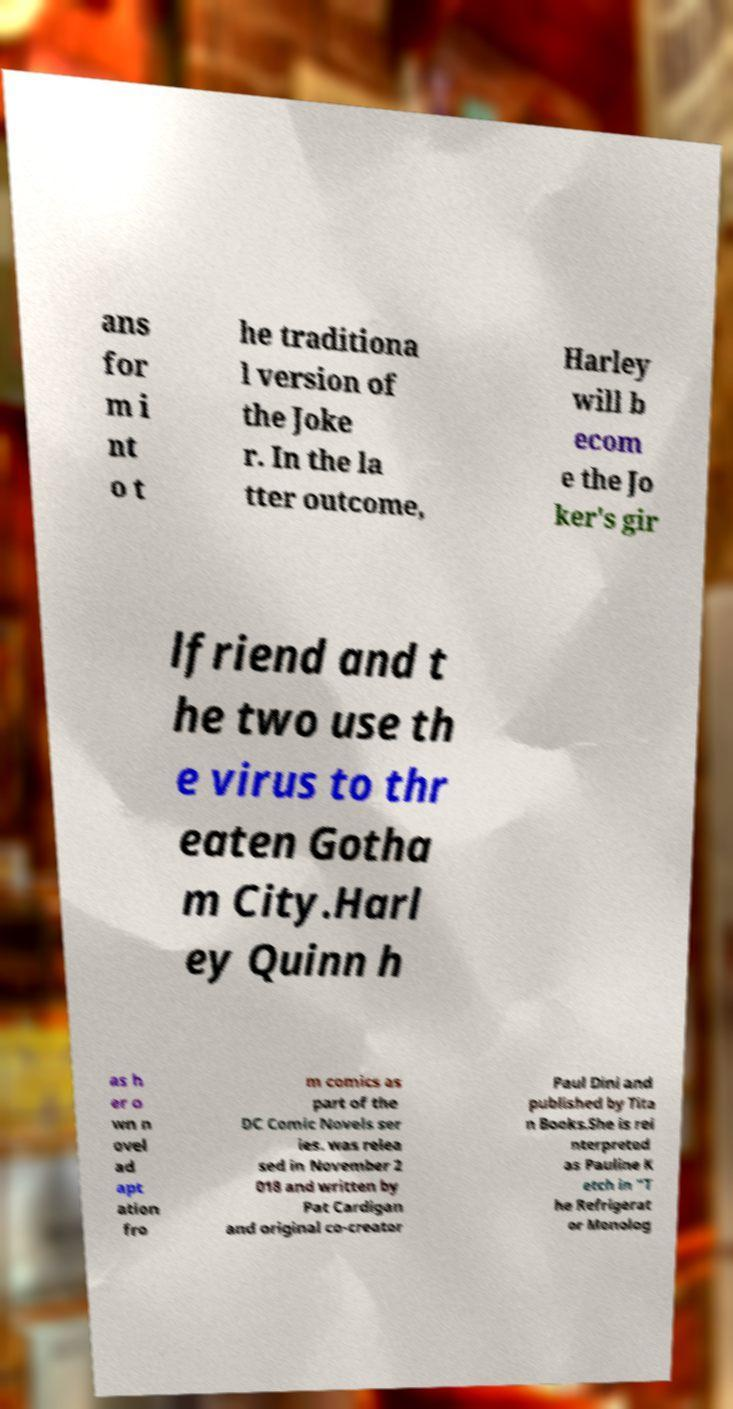Could you assist in decoding the text presented in this image and type it out clearly? ans for m i nt o t he traditiona l version of the Joke r. In the la tter outcome, Harley will b ecom e the Jo ker's gir lfriend and t he two use th e virus to thr eaten Gotha m City.Harl ey Quinn h as h er o wn n ovel ad apt ation fro m comics as part of the DC Comic Novels ser ies. was relea sed in November 2 018 and written by Pat Cardigan and original co-creator Paul Dini and published by Tita n Books.She is rei nterpreted as Pauline K etch in "T he Refrigerat or Monolog 